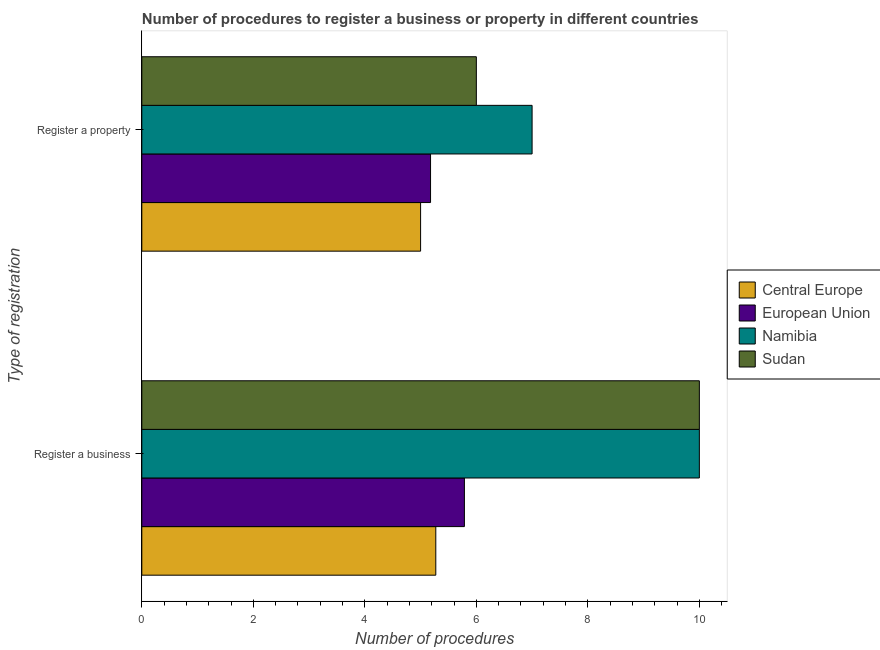Are the number of bars per tick equal to the number of legend labels?
Keep it short and to the point. Yes. Are the number of bars on each tick of the Y-axis equal?
Offer a terse response. Yes. How many bars are there on the 1st tick from the bottom?
Provide a succinct answer. 4. What is the label of the 1st group of bars from the top?
Provide a short and direct response. Register a property. What is the number of procedures to register a business in Sudan?
Make the answer very short. 10. Across all countries, what is the minimum number of procedures to register a business?
Your response must be concise. 5.27. In which country was the number of procedures to register a property maximum?
Make the answer very short. Namibia. In which country was the number of procedures to register a business minimum?
Offer a very short reply. Central Europe. What is the total number of procedures to register a property in the graph?
Offer a very short reply. 23.18. What is the difference between the number of procedures to register a property in Sudan and that in European Union?
Keep it short and to the point. 0.82. What is the difference between the number of procedures to register a property in Sudan and the number of procedures to register a business in Namibia?
Offer a very short reply. -4. What is the average number of procedures to register a property per country?
Your response must be concise. 5.79. In how many countries, is the number of procedures to register a business greater than 6.4 ?
Give a very brief answer. 2. What is the ratio of the number of procedures to register a business in Central Europe to that in Namibia?
Provide a succinct answer. 0.53. What does the 4th bar from the top in Register a property represents?
Provide a succinct answer. Central Europe. What does the 3rd bar from the bottom in Register a business represents?
Make the answer very short. Namibia. How many bars are there?
Offer a terse response. 8. What is the difference between two consecutive major ticks on the X-axis?
Offer a terse response. 2. Does the graph contain any zero values?
Your response must be concise. No. Where does the legend appear in the graph?
Offer a very short reply. Center right. How many legend labels are there?
Give a very brief answer. 4. What is the title of the graph?
Offer a very short reply. Number of procedures to register a business or property in different countries. Does "Gabon" appear as one of the legend labels in the graph?
Your answer should be very brief. No. What is the label or title of the X-axis?
Make the answer very short. Number of procedures. What is the label or title of the Y-axis?
Provide a succinct answer. Type of registration. What is the Number of procedures of Central Europe in Register a business?
Your response must be concise. 5.27. What is the Number of procedures of European Union in Register a business?
Your answer should be very brief. 5.79. What is the Number of procedures of Namibia in Register a business?
Provide a short and direct response. 10. What is the Number of procedures of Sudan in Register a business?
Keep it short and to the point. 10. What is the Number of procedures of European Union in Register a property?
Give a very brief answer. 5.18. What is the Number of procedures of Namibia in Register a property?
Offer a very short reply. 7. Across all Type of registration, what is the maximum Number of procedures of Central Europe?
Give a very brief answer. 5.27. Across all Type of registration, what is the maximum Number of procedures of European Union?
Your answer should be very brief. 5.79. Across all Type of registration, what is the minimum Number of procedures in Central Europe?
Provide a succinct answer. 5. Across all Type of registration, what is the minimum Number of procedures in European Union?
Offer a very short reply. 5.18. Across all Type of registration, what is the minimum Number of procedures of Namibia?
Your answer should be compact. 7. Across all Type of registration, what is the minimum Number of procedures in Sudan?
Offer a very short reply. 6. What is the total Number of procedures of Central Europe in the graph?
Your answer should be compact. 10.27. What is the total Number of procedures of European Union in the graph?
Your response must be concise. 10.96. What is the difference between the Number of procedures of Central Europe in Register a business and that in Register a property?
Your response must be concise. 0.27. What is the difference between the Number of procedures of European Union in Register a business and that in Register a property?
Provide a succinct answer. 0.61. What is the difference between the Number of procedures of Central Europe in Register a business and the Number of procedures of European Union in Register a property?
Your answer should be compact. 0.09. What is the difference between the Number of procedures in Central Europe in Register a business and the Number of procedures in Namibia in Register a property?
Offer a very short reply. -1.73. What is the difference between the Number of procedures in Central Europe in Register a business and the Number of procedures in Sudan in Register a property?
Give a very brief answer. -0.73. What is the difference between the Number of procedures in European Union in Register a business and the Number of procedures in Namibia in Register a property?
Offer a terse response. -1.21. What is the difference between the Number of procedures of European Union in Register a business and the Number of procedures of Sudan in Register a property?
Provide a short and direct response. -0.21. What is the difference between the Number of procedures in Namibia in Register a business and the Number of procedures in Sudan in Register a property?
Provide a succinct answer. 4. What is the average Number of procedures of Central Europe per Type of registration?
Provide a short and direct response. 5.14. What is the average Number of procedures in European Union per Type of registration?
Your response must be concise. 5.48. What is the difference between the Number of procedures in Central Europe and Number of procedures in European Union in Register a business?
Offer a very short reply. -0.51. What is the difference between the Number of procedures in Central Europe and Number of procedures in Namibia in Register a business?
Offer a terse response. -4.73. What is the difference between the Number of procedures in Central Europe and Number of procedures in Sudan in Register a business?
Offer a very short reply. -4.73. What is the difference between the Number of procedures in European Union and Number of procedures in Namibia in Register a business?
Keep it short and to the point. -4.21. What is the difference between the Number of procedures of European Union and Number of procedures of Sudan in Register a business?
Your response must be concise. -4.21. What is the difference between the Number of procedures of Central Europe and Number of procedures of European Union in Register a property?
Provide a short and direct response. -0.18. What is the difference between the Number of procedures of Central Europe and Number of procedures of Sudan in Register a property?
Ensure brevity in your answer.  -1. What is the difference between the Number of procedures of European Union and Number of procedures of Namibia in Register a property?
Ensure brevity in your answer.  -1.82. What is the difference between the Number of procedures of European Union and Number of procedures of Sudan in Register a property?
Your response must be concise. -0.82. What is the difference between the Number of procedures of Namibia and Number of procedures of Sudan in Register a property?
Your answer should be compact. 1. What is the ratio of the Number of procedures of Central Europe in Register a business to that in Register a property?
Provide a succinct answer. 1.05. What is the ratio of the Number of procedures of European Union in Register a business to that in Register a property?
Your answer should be compact. 1.12. What is the ratio of the Number of procedures of Namibia in Register a business to that in Register a property?
Provide a succinct answer. 1.43. What is the ratio of the Number of procedures of Sudan in Register a business to that in Register a property?
Ensure brevity in your answer.  1.67. What is the difference between the highest and the second highest Number of procedures of Central Europe?
Offer a terse response. 0.27. What is the difference between the highest and the second highest Number of procedures of European Union?
Make the answer very short. 0.61. What is the difference between the highest and the second highest Number of procedures in Namibia?
Provide a short and direct response. 3. What is the difference between the highest and the second highest Number of procedures in Sudan?
Ensure brevity in your answer.  4. What is the difference between the highest and the lowest Number of procedures of Central Europe?
Provide a succinct answer. 0.27. What is the difference between the highest and the lowest Number of procedures of European Union?
Provide a short and direct response. 0.61. What is the difference between the highest and the lowest Number of procedures in Namibia?
Your answer should be compact. 3. What is the difference between the highest and the lowest Number of procedures in Sudan?
Your answer should be very brief. 4. 